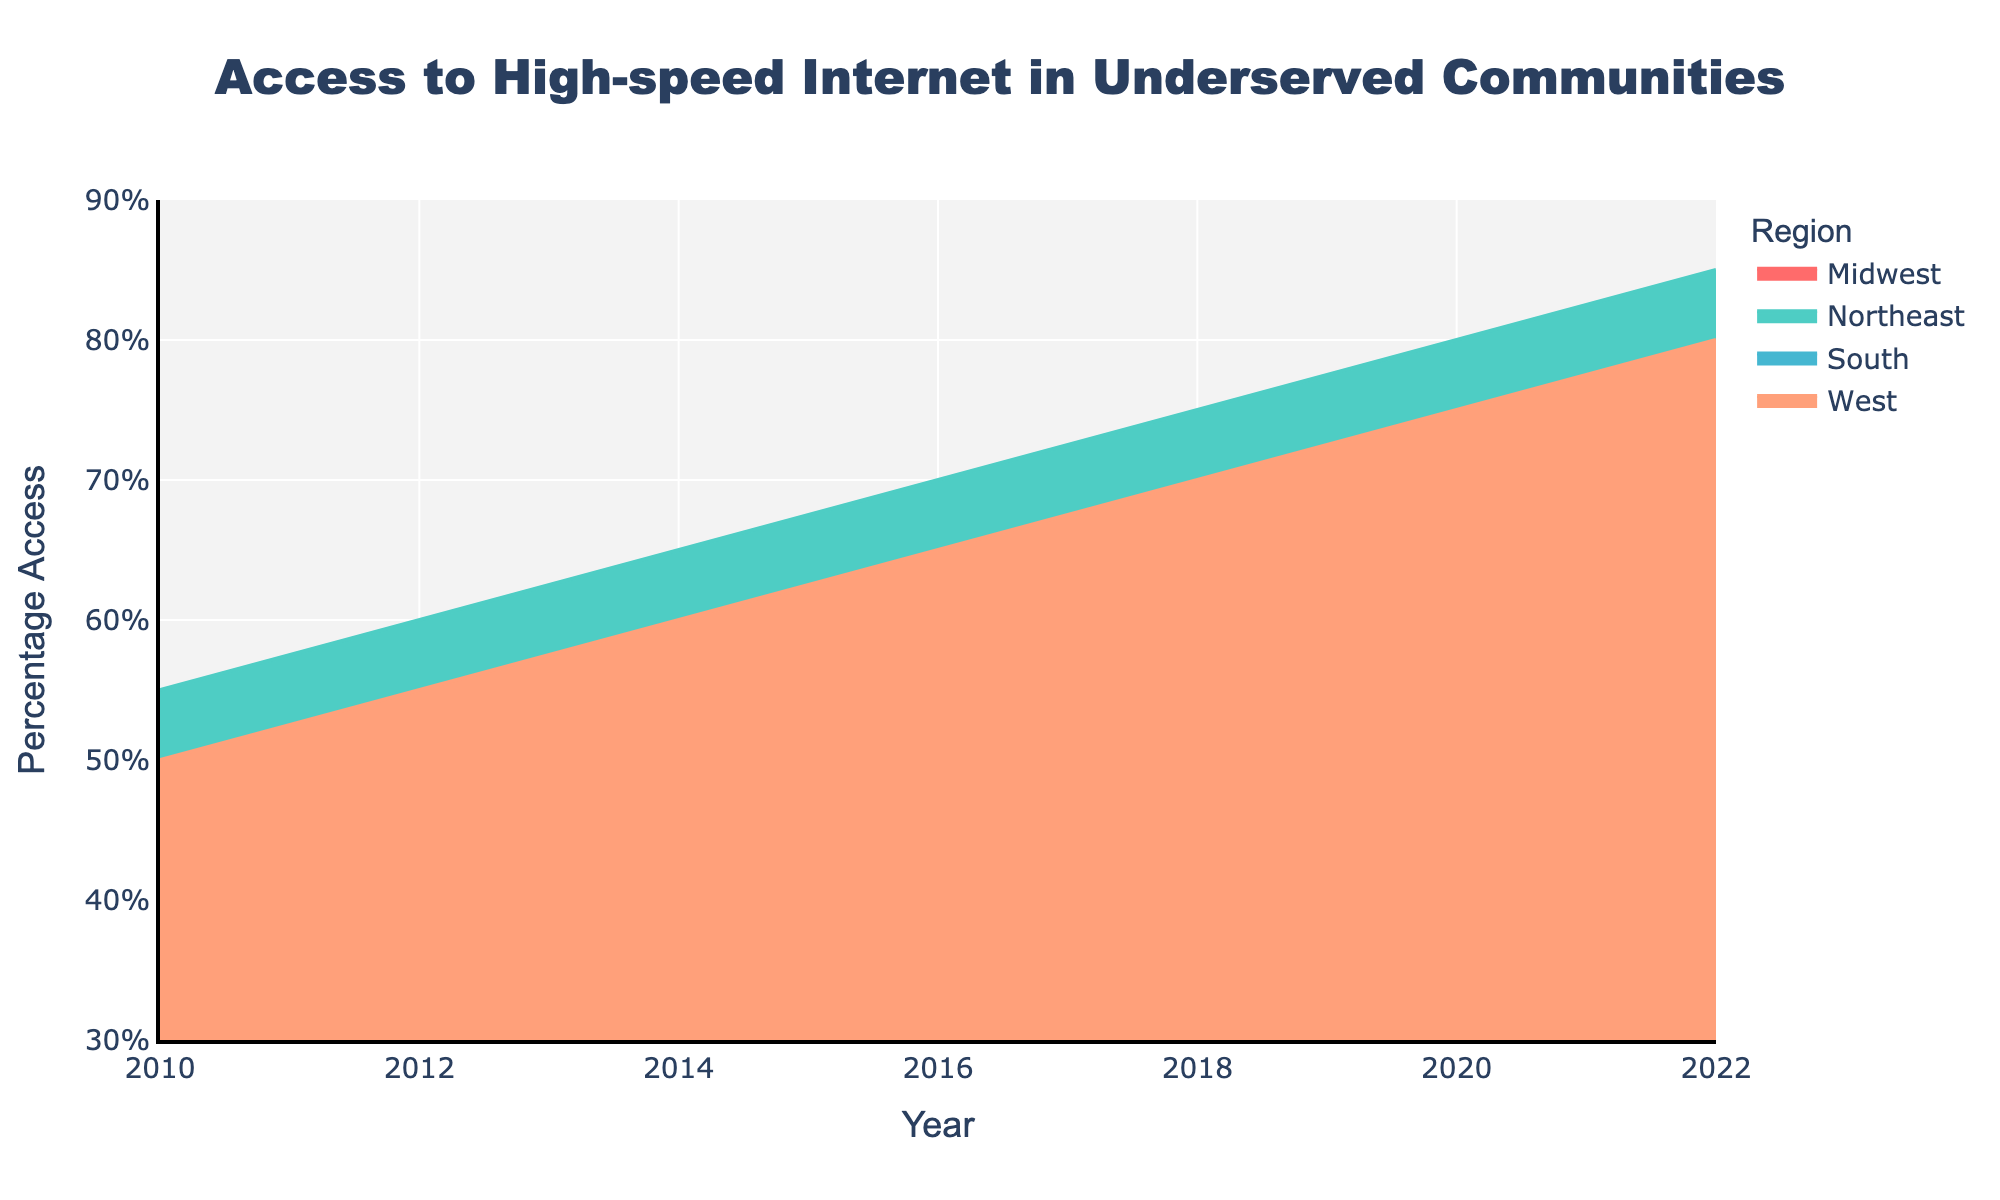What is the title of the figure? The title is displayed prominently at the top of the figure. It provides a general overview of what the chart represents.
Answer: Access to High-speed Internet in Underserved Communities What is the percentage access to high-speed internet in the Northeast region in 2022? Locate the Northeast region's shaded area on the chart and trace it to the year 2022. The y-axis value corresponding to this year is the percentage access.
Answer: 85% Between which years did the South region see the highest increase in percentage access to high-speed internet? Identify the data points for the South region and calculate the differences between consecutive years. The pair of years with the highest difference represents the highest increase.
Answer: 2018 to 2020 What is the difference in percentage access between the Midwest and West regions in 2016? Find the y-axis values for both the Midwest and the West regions in 2016. Subtract the Midwest's value from the West's value to get the difference.
Answer: 3% How many regions are represented in the figure? Follow different colored areas or check the legend to count the unique regions represented in the figure.
Answer: 4 Which region had the lowest percentage access in 2010, and what was it? Locate the data points for 2010 on the figure and identify the region with the smallest y-axis value. This represents the lowest percentage access.
Answer: South, 38% On average, how much did percentage access to high-speed internet increase per region between 2010 and 2022? Calculate the total percentage increase for each region between 2010 and 2022. Then, add these values and divide by the number of regions to find the average increase.
Answer: 30% Which region has consistently shown the highest percentage access to high-speed internet from 2010 to 2022? Look at the shaded areas over the entire time period and identify which one consistently stays the highest across all years.
Answer: Northeast By how much did the percentage access to high-speed internet in the West region change from 2010 to 2022? Locate the West region's data points for 2010 and 2022 and subtract the percentage in 2010 from the percentage in 2022 to find the change.
Answer: 30% How does the increase in percentage access to high-speed internet between 2010 and 2022 in the Midwest compare to that in the South? Calculate the change for both the Midwest and South regions from 2010 to 2022 and compare the two values.
Answer: Midwest increased by 33%, South increased by 34% 